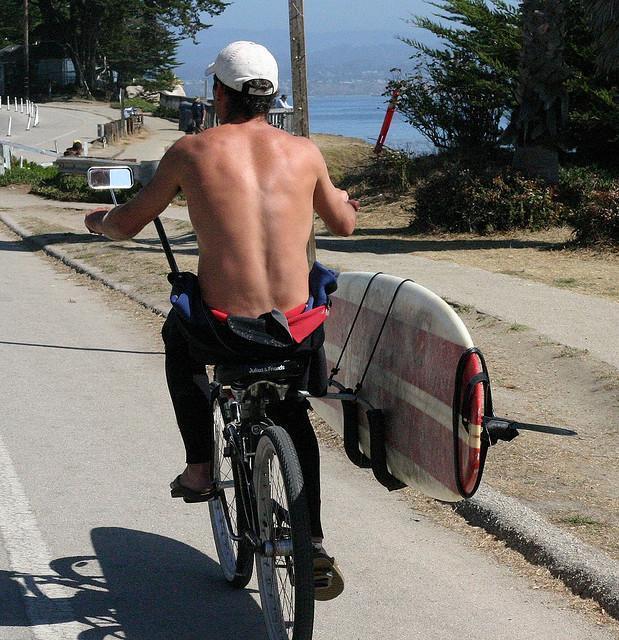How many bicycles are pictured?
Give a very brief answer. 1. How many people are visible?
Give a very brief answer. 1. 